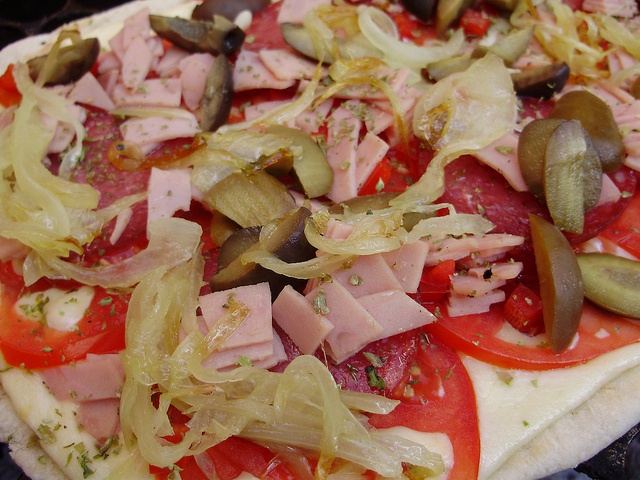Describe the objects in this image and their specific colors. I can see a pizza in tan, gray, maroon, and brown tones in this image. 